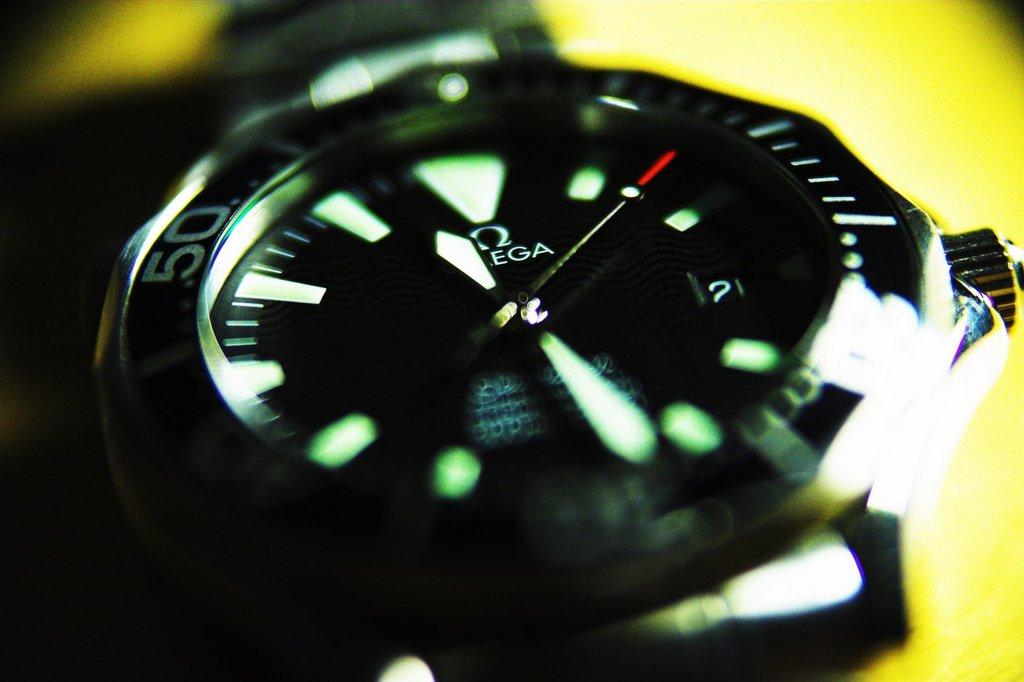What is the brand of this watch?
Offer a very short reply. Omega. What time is it?
Make the answer very short. 11:30. 